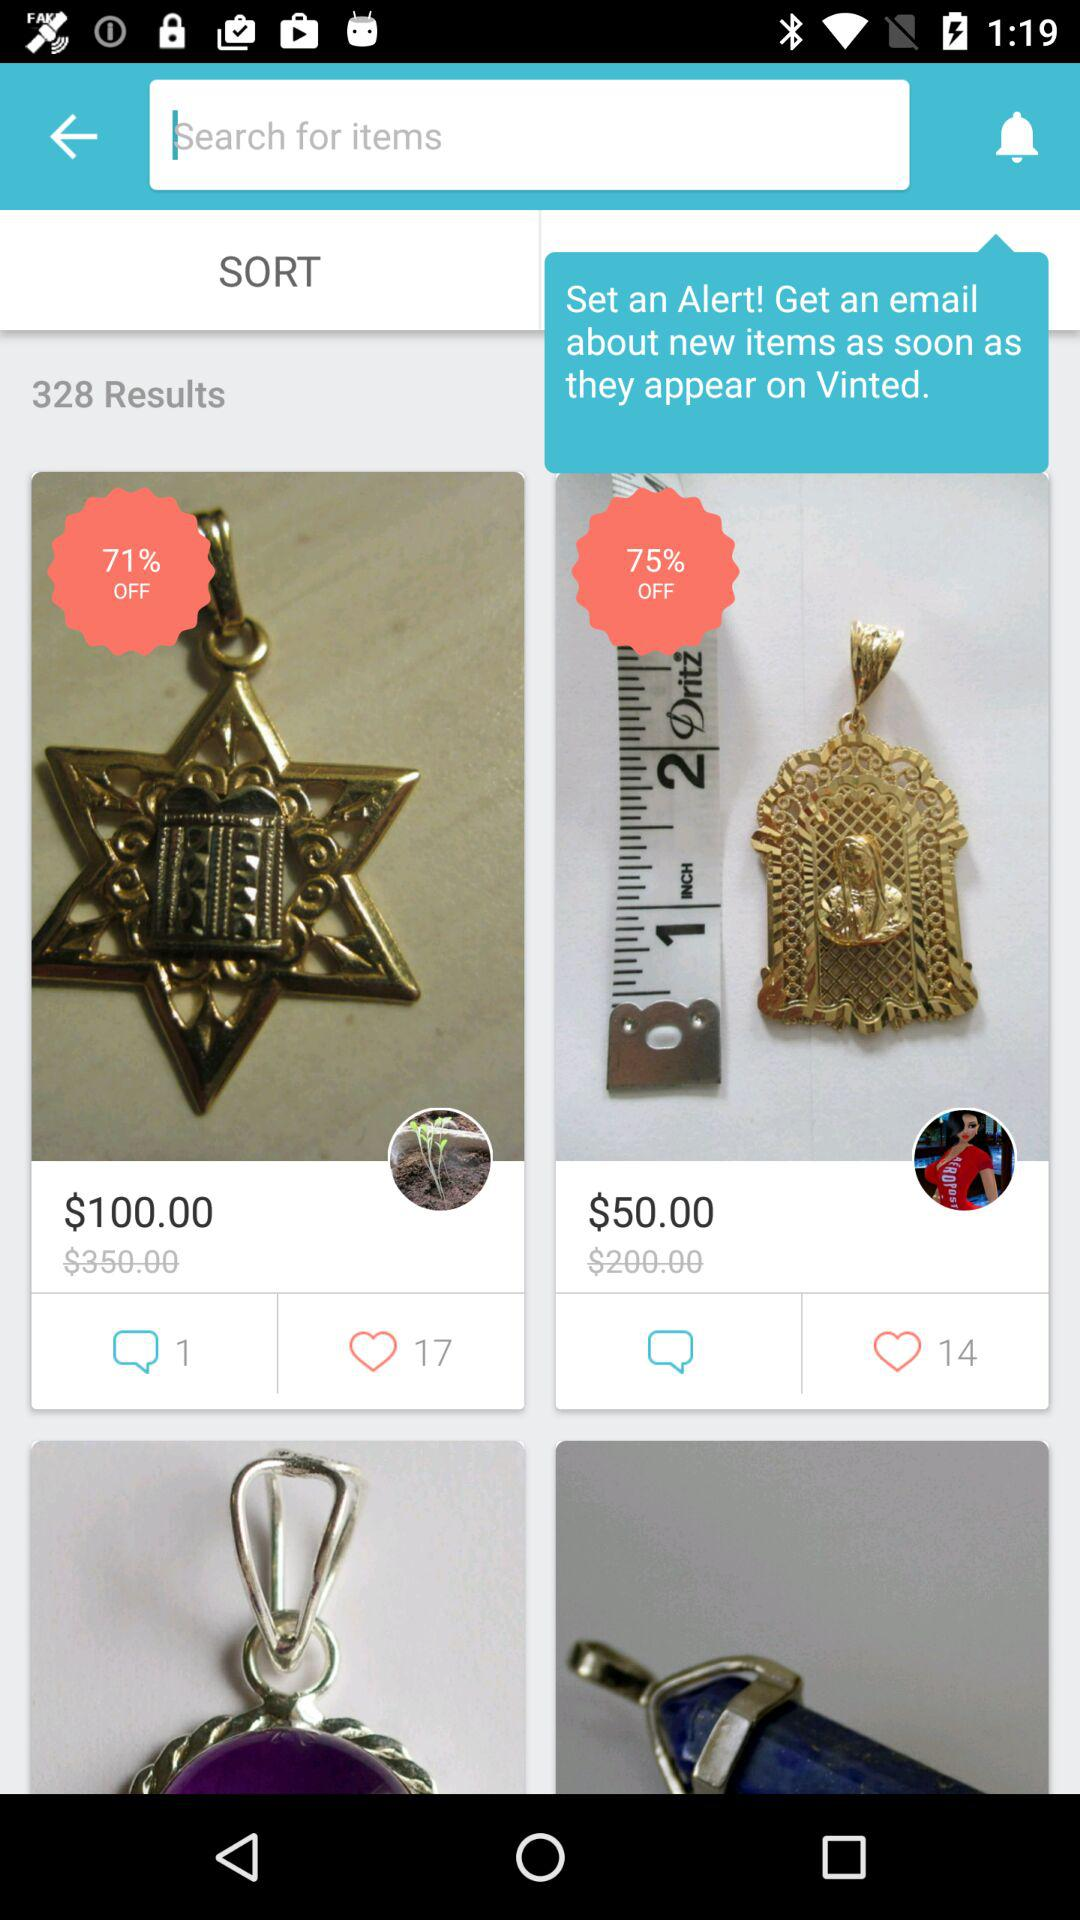How many likes does a $50.00 product have? A $50.00 product has 14 likes. 